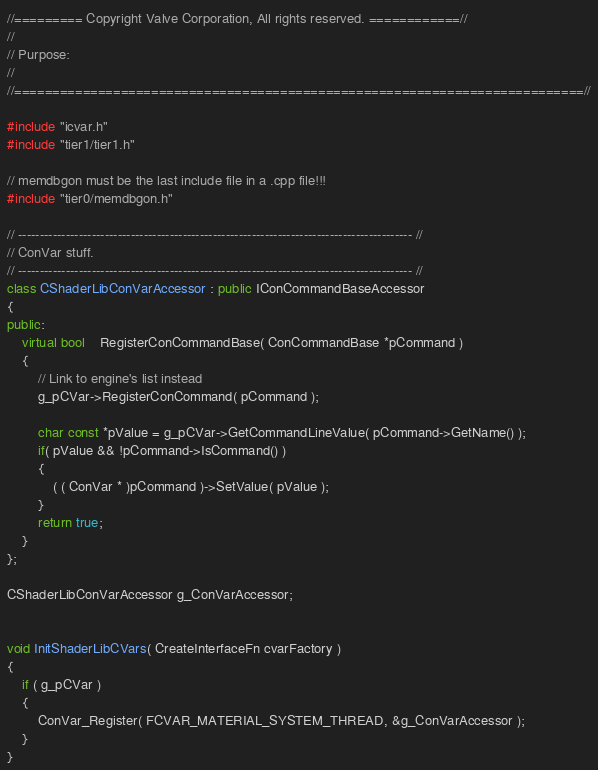Convert code to text. <code><loc_0><loc_0><loc_500><loc_500><_C++_>//========= Copyright Valve Corporation, All rights reserved. ============//
//
// Purpose: 
//
//===========================================================================//

#include "icvar.h"
#include "tier1/tier1.h"

// memdbgon must be the last include file in a .cpp file!!!
#include "tier0/memdbgon.h"

// ------------------------------------------------------------------------------------------- //
// ConVar stuff.
// ------------------------------------------------------------------------------------------- //
class CShaderLibConVarAccessor : public IConCommandBaseAccessor
{
public:
	virtual bool	RegisterConCommandBase( ConCommandBase *pCommand )
	{
		// Link to engine's list instead
		g_pCVar->RegisterConCommand( pCommand );

		char const *pValue = g_pCVar->GetCommandLineValue( pCommand->GetName() );
		if( pValue && !pCommand->IsCommand() )
		{
			( ( ConVar * )pCommand )->SetValue( pValue );
		}
		return true;
	}
};

CShaderLibConVarAccessor g_ConVarAccessor;


void InitShaderLibCVars( CreateInterfaceFn cvarFactory )
{
	if ( g_pCVar )
	{
		ConVar_Register( FCVAR_MATERIAL_SYSTEM_THREAD, &g_ConVarAccessor );
	}
}
</code> 